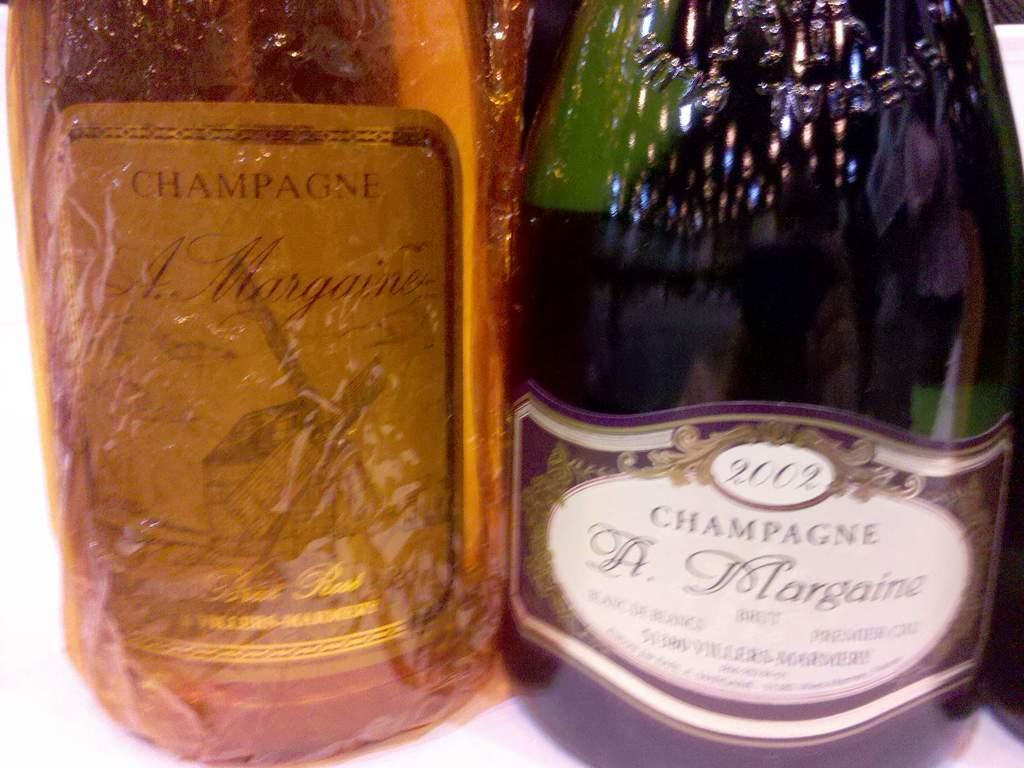<image>
Share a concise interpretation of the image provided. a champagne bottle next to another bottle with orange in it 